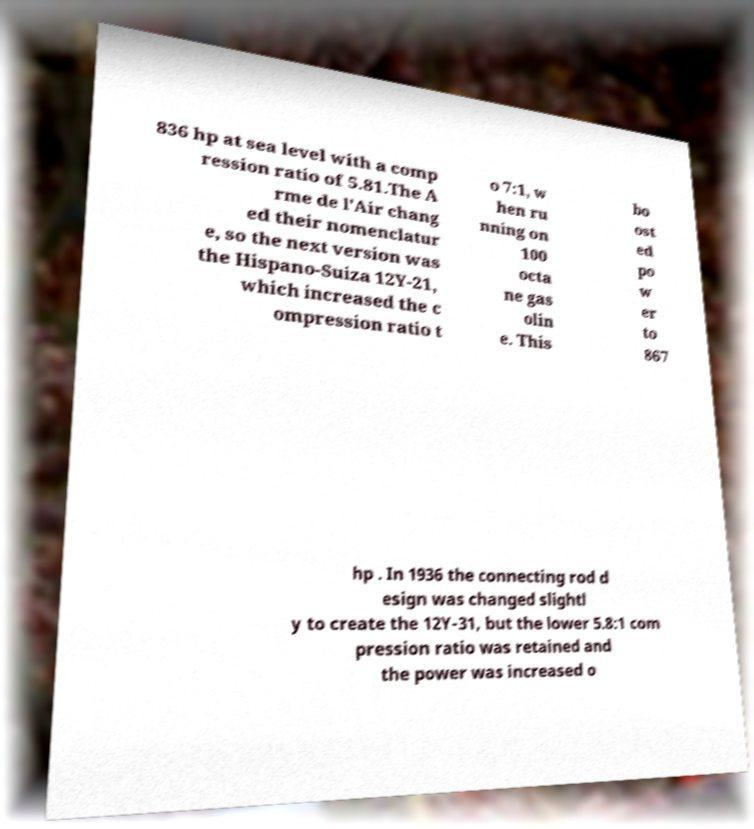Can you accurately transcribe the text from the provided image for me? 836 hp at sea level with a comp ression ratio of 5.81.The A rme de l'Air chang ed their nomenclatur e, so the next version was the Hispano-Suiza 12Y-21, which increased the c ompression ratio t o 7:1, w hen ru nning on 100 octa ne gas olin e. This bo ost ed po w er to 867 hp . In 1936 the connecting rod d esign was changed slightl y to create the 12Y-31, but the lower 5.8:1 com pression ratio was retained and the power was increased o 